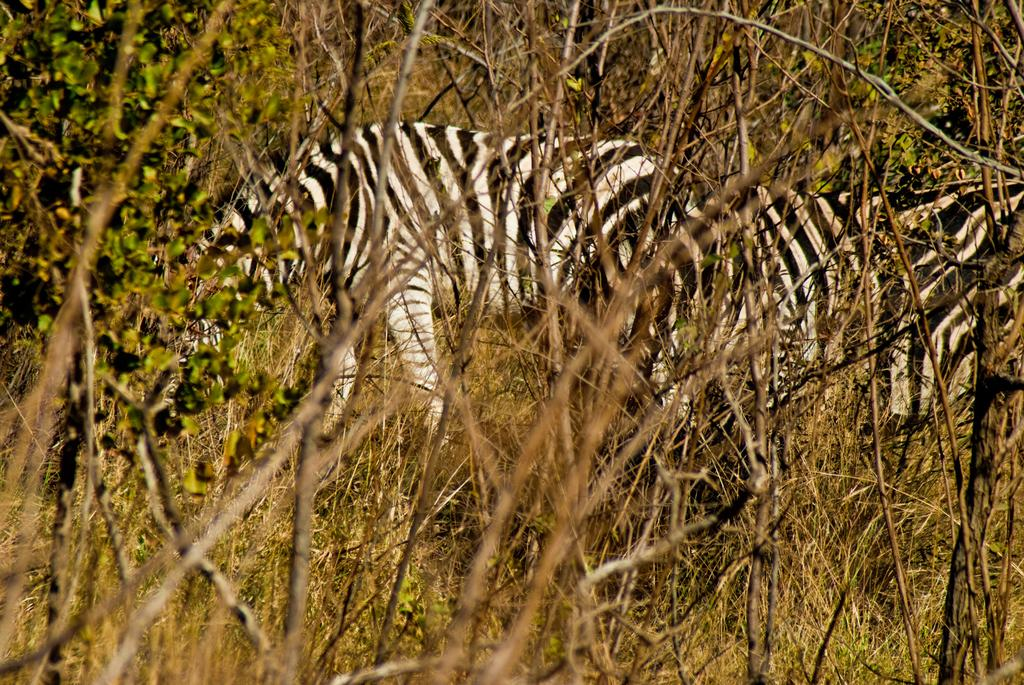What animals are standing in the image? There are zebras standing in the image. What can be seen in the distance behind the zebras? There are trees in the background of the image. What type of vegetation is visible at the bottom of the image? There are plants visible at the bottom of the image. What bone is being used to blow a horn in the image? There is no bone or horn present in the image; it features zebras standing in front of trees and plants. 